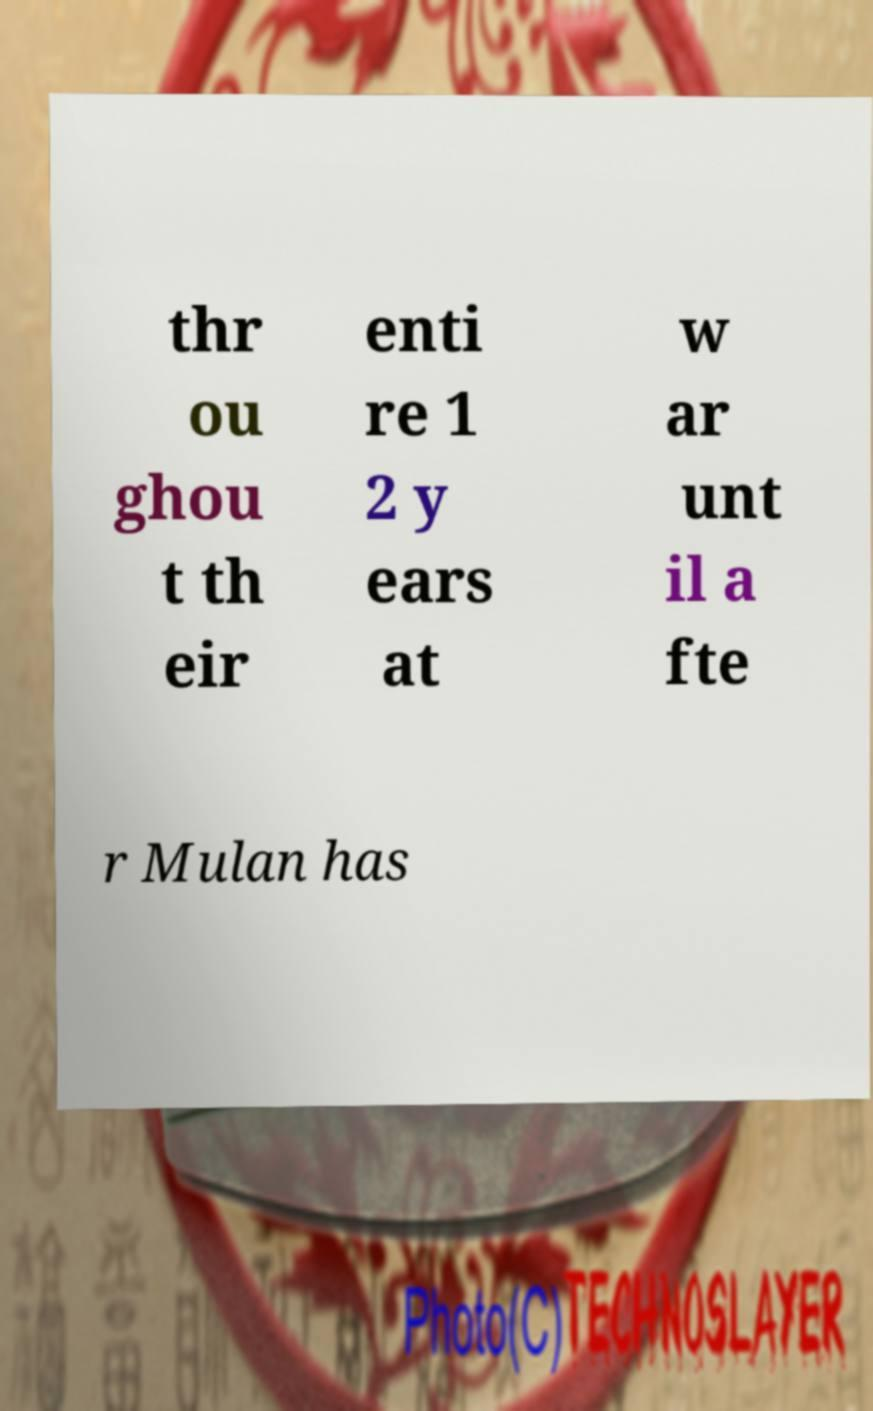What messages or text are displayed in this image? I need them in a readable, typed format. thr ou ghou t th eir enti re 1 2 y ears at w ar unt il a fte r Mulan has 